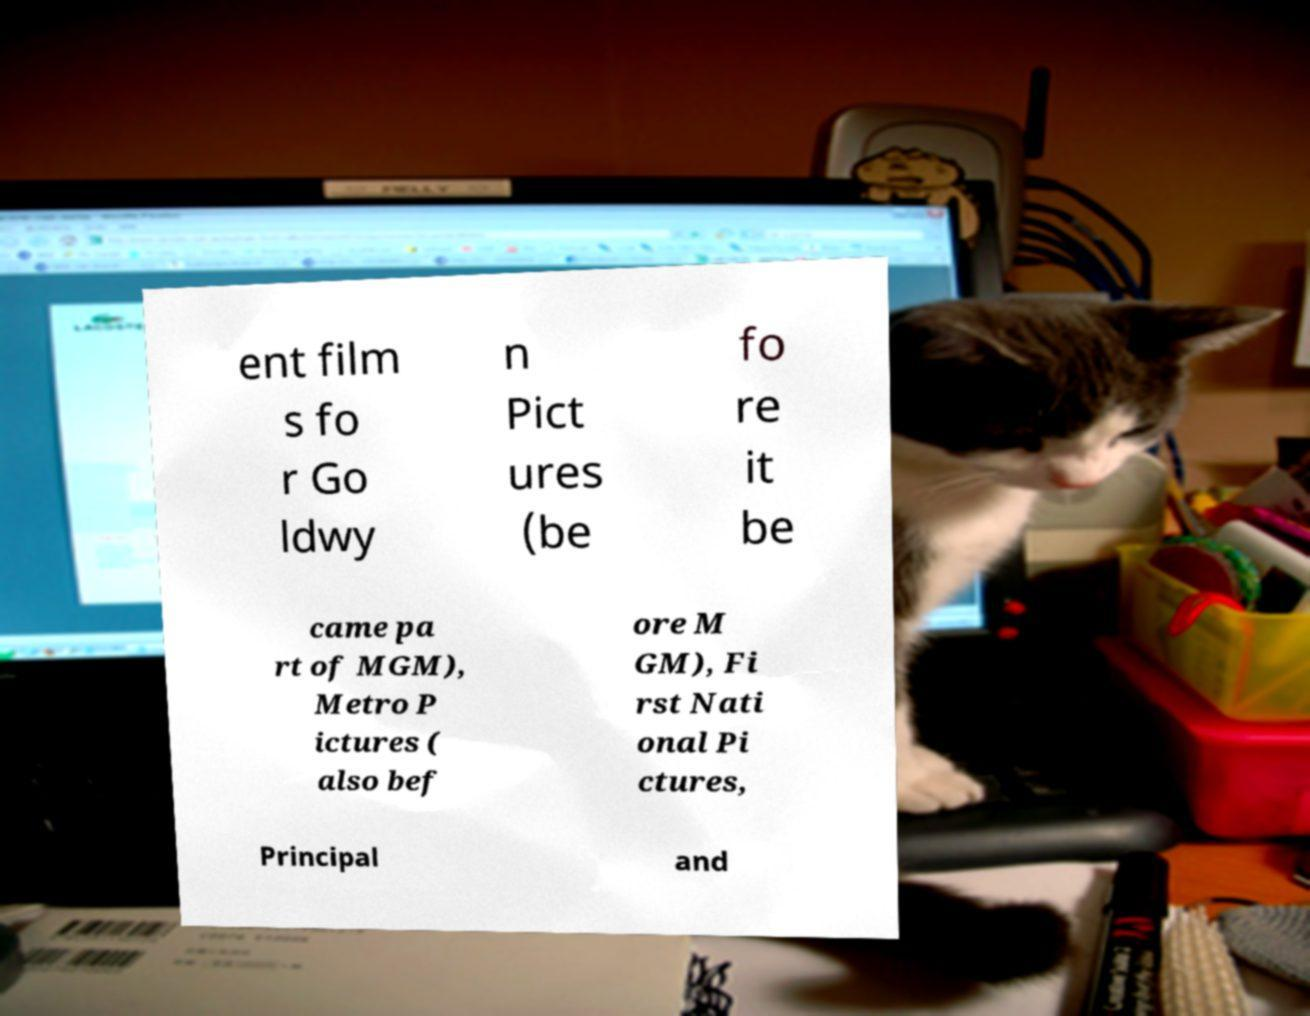Could you extract and type out the text from this image? ent film s fo r Go ldwy n Pict ures (be fo re it be came pa rt of MGM), Metro P ictures ( also bef ore M GM), Fi rst Nati onal Pi ctures, Principal and 